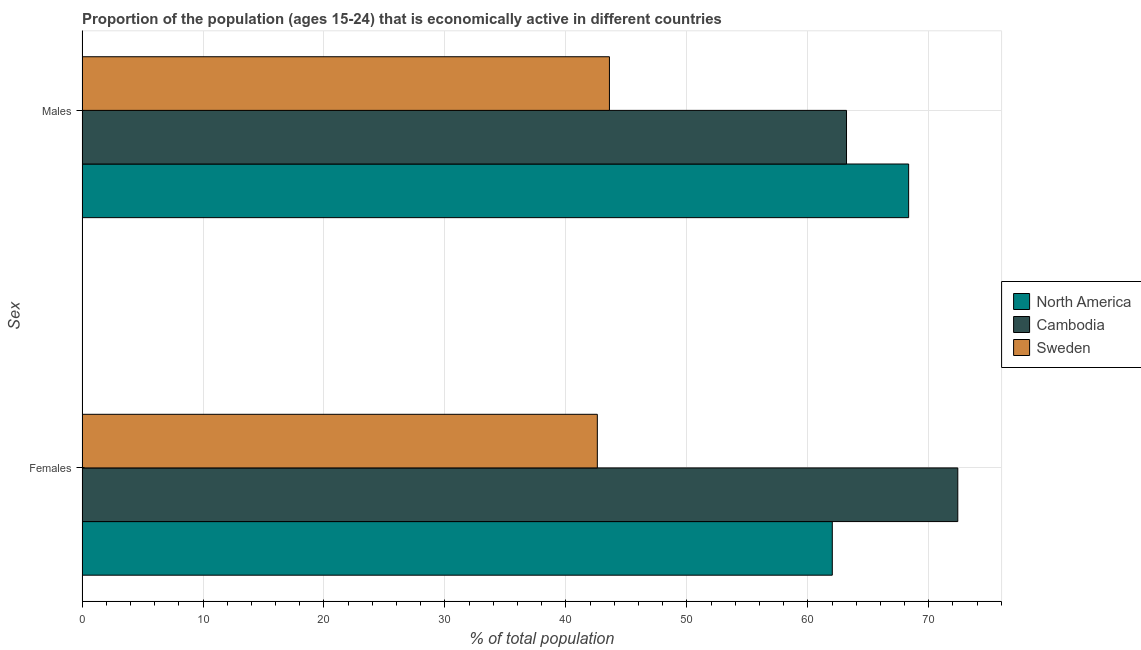How many groups of bars are there?
Provide a short and direct response. 2. How many bars are there on the 2nd tick from the top?
Your answer should be compact. 3. What is the label of the 1st group of bars from the top?
Provide a succinct answer. Males. What is the percentage of economically active male population in North America?
Offer a very short reply. 68.34. Across all countries, what is the maximum percentage of economically active male population?
Make the answer very short. 68.34. Across all countries, what is the minimum percentage of economically active female population?
Offer a very short reply. 42.6. In which country was the percentage of economically active male population maximum?
Your response must be concise. North America. What is the total percentage of economically active female population in the graph?
Keep it short and to the point. 177.02. What is the difference between the percentage of economically active female population in Cambodia and that in Sweden?
Your answer should be compact. 29.8. What is the difference between the percentage of economically active female population in Cambodia and the percentage of economically active male population in North America?
Your response must be concise. 4.06. What is the average percentage of economically active female population per country?
Make the answer very short. 59.01. What is the ratio of the percentage of economically active male population in Cambodia to that in Sweden?
Your answer should be compact. 1.45. Is the percentage of economically active female population in Sweden less than that in Cambodia?
Make the answer very short. Yes. What does the 3rd bar from the top in Males represents?
Offer a terse response. North America. What does the 2nd bar from the bottom in Males represents?
Offer a terse response. Cambodia. How many bars are there?
Make the answer very short. 6. Are all the bars in the graph horizontal?
Your answer should be very brief. Yes. How many countries are there in the graph?
Give a very brief answer. 3. What is the difference between two consecutive major ticks on the X-axis?
Your answer should be compact. 10. Does the graph contain grids?
Your answer should be very brief. Yes. How are the legend labels stacked?
Ensure brevity in your answer.  Vertical. What is the title of the graph?
Your answer should be compact. Proportion of the population (ages 15-24) that is economically active in different countries. Does "Middle income" appear as one of the legend labels in the graph?
Provide a succinct answer. No. What is the label or title of the X-axis?
Provide a short and direct response. % of total population. What is the label or title of the Y-axis?
Ensure brevity in your answer.  Sex. What is the % of total population in North America in Females?
Your answer should be very brief. 62.02. What is the % of total population of Cambodia in Females?
Your response must be concise. 72.4. What is the % of total population of Sweden in Females?
Keep it short and to the point. 42.6. What is the % of total population in North America in Males?
Your response must be concise. 68.34. What is the % of total population in Cambodia in Males?
Your answer should be compact. 63.2. What is the % of total population in Sweden in Males?
Your answer should be very brief. 43.6. Across all Sex, what is the maximum % of total population of North America?
Your answer should be very brief. 68.34. Across all Sex, what is the maximum % of total population of Cambodia?
Give a very brief answer. 72.4. Across all Sex, what is the maximum % of total population of Sweden?
Keep it short and to the point. 43.6. Across all Sex, what is the minimum % of total population in North America?
Your answer should be compact. 62.02. Across all Sex, what is the minimum % of total population in Cambodia?
Make the answer very short. 63.2. Across all Sex, what is the minimum % of total population in Sweden?
Offer a very short reply. 42.6. What is the total % of total population of North America in the graph?
Your response must be concise. 130.36. What is the total % of total population in Cambodia in the graph?
Give a very brief answer. 135.6. What is the total % of total population in Sweden in the graph?
Give a very brief answer. 86.2. What is the difference between the % of total population of North America in Females and that in Males?
Keep it short and to the point. -6.31. What is the difference between the % of total population in Cambodia in Females and that in Males?
Give a very brief answer. 9.2. What is the difference between the % of total population of North America in Females and the % of total population of Cambodia in Males?
Provide a succinct answer. -1.18. What is the difference between the % of total population in North America in Females and the % of total population in Sweden in Males?
Provide a short and direct response. 18.42. What is the difference between the % of total population in Cambodia in Females and the % of total population in Sweden in Males?
Provide a succinct answer. 28.8. What is the average % of total population in North America per Sex?
Keep it short and to the point. 65.18. What is the average % of total population in Cambodia per Sex?
Offer a terse response. 67.8. What is the average % of total population of Sweden per Sex?
Provide a succinct answer. 43.1. What is the difference between the % of total population in North America and % of total population in Cambodia in Females?
Give a very brief answer. -10.38. What is the difference between the % of total population in North America and % of total population in Sweden in Females?
Give a very brief answer. 19.42. What is the difference between the % of total population of Cambodia and % of total population of Sweden in Females?
Keep it short and to the point. 29.8. What is the difference between the % of total population of North America and % of total population of Cambodia in Males?
Your answer should be compact. 5.14. What is the difference between the % of total population in North America and % of total population in Sweden in Males?
Your response must be concise. 24.74. What is the difference between the % of total population of Cambodia and % of total population of Sweden in Males?
Ensure brevity in your answer.  19.6. What is the ratio of the % of total population of North America in Females to that in Males?
Make the answer very short. 0.91. What is the ratio of the % of total population in Cambodia in Females to that in Males?
Your response must be concise. 1.15. What is the ratio of the % of total population in Sweden in Females to that in Males?
Make the answer very short. 0.98. What is the difference between the highest and the second highest % of total population of North America?
Provide a short and direct response. 6.31. What is the difference between the highest and the second highest % of total population of Sweden?
Provide a succinct answer. 1. What is the difference between the highest and the lowest % of total population of North America?
Ensure brevity in your answer.  6.31. What is the difference between the highest and the lowest % of total population in Sweden?
Your answer should be compact. 1. 